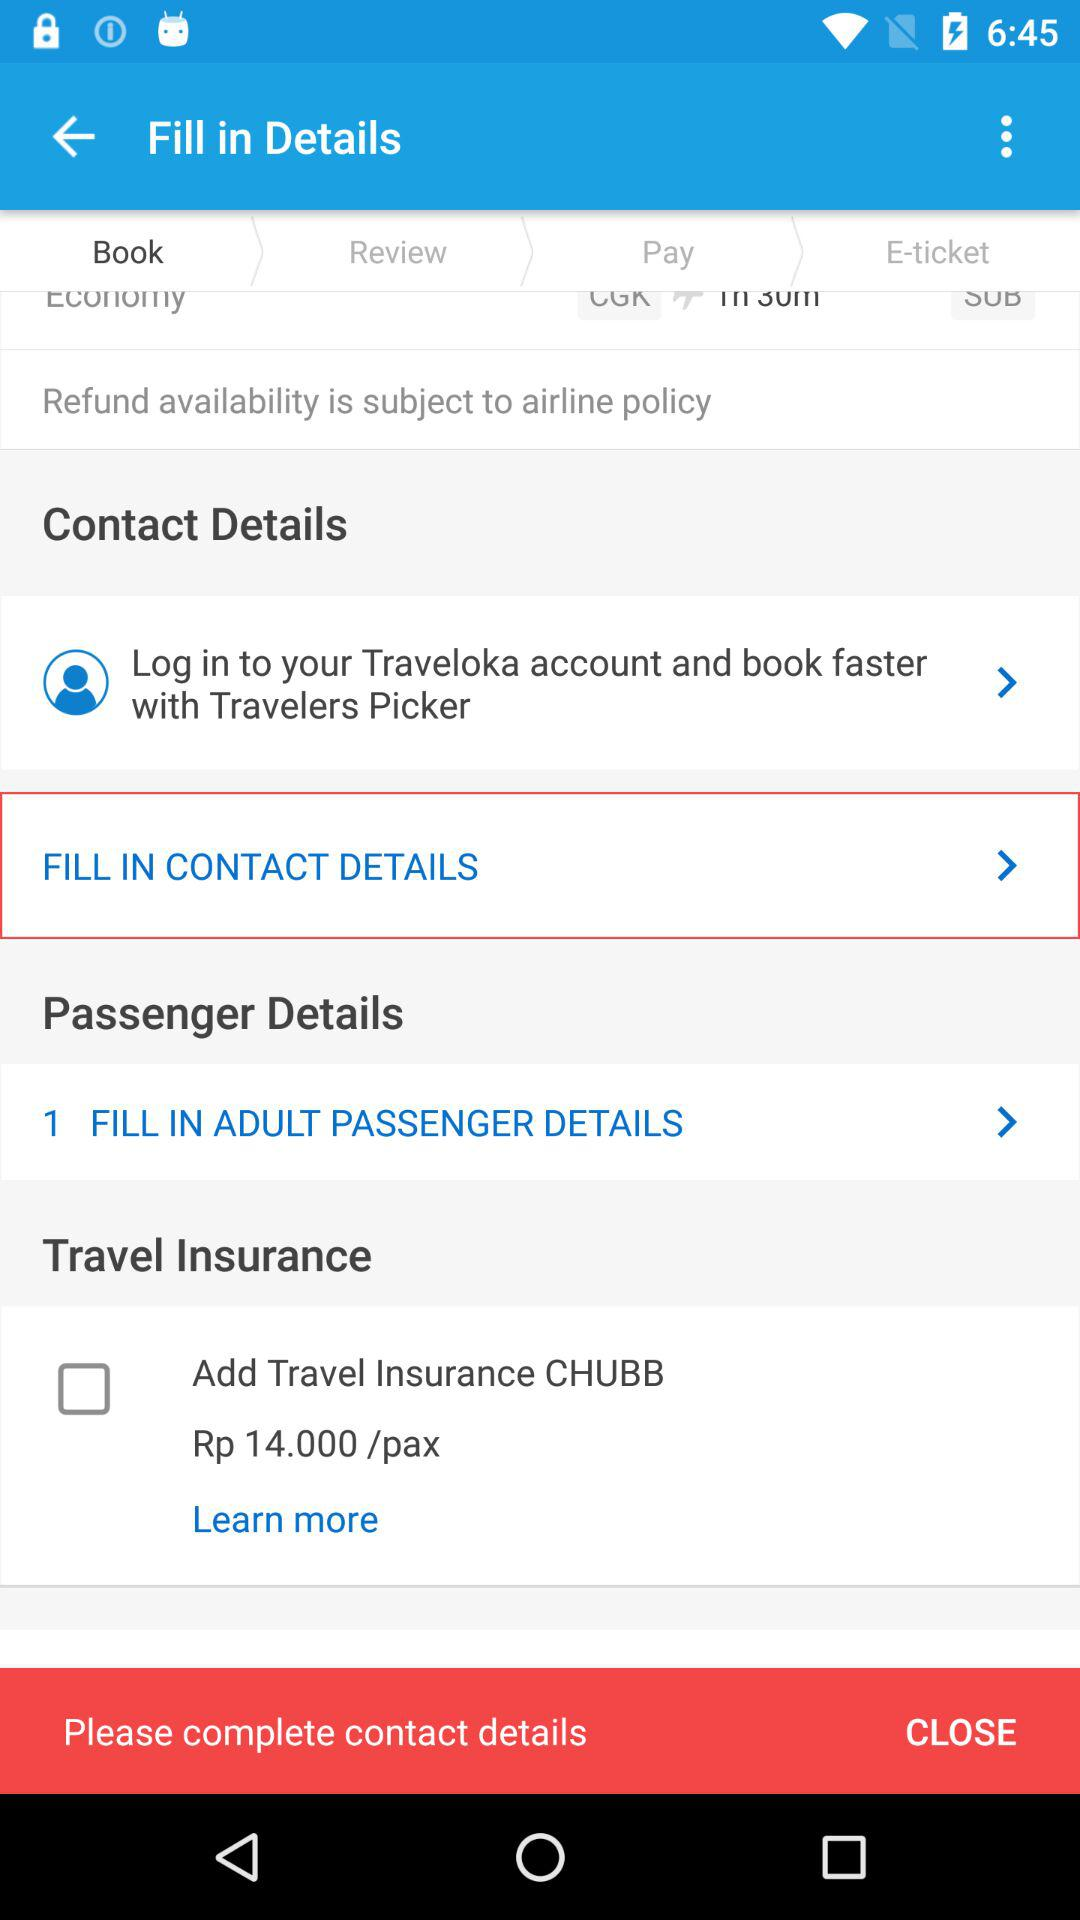What is the app name? The app name is "Traveloka". 